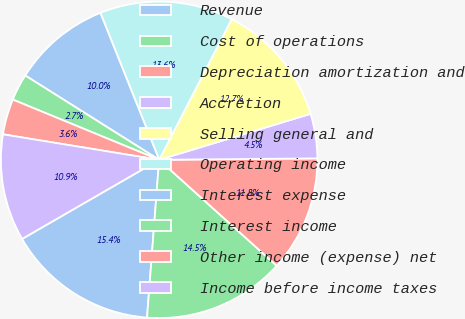Convert chart to OTSL. <chart><loc_0><loc_0><loc_500><loc_500><pie_chart><fcel>Revenue<fcel>Cost of operations<fcel>Depreciation amortization and<fcel>Accretion<fcel>Selling general and<fcel>Operating income<fcel>Interest expense<fcel>Interest income<fcel>Other income (expense) net<fcel>Income before income taxes<nl><fcel>15.45%<fcel>14.55%<fcel>11.82%<fcel>4.55%<fcel>12.73%<fcel>13.64%<fcel>10.0%<fcel>2.73%<fcel>3.64%<fcel>10.91%<nl></chart> 